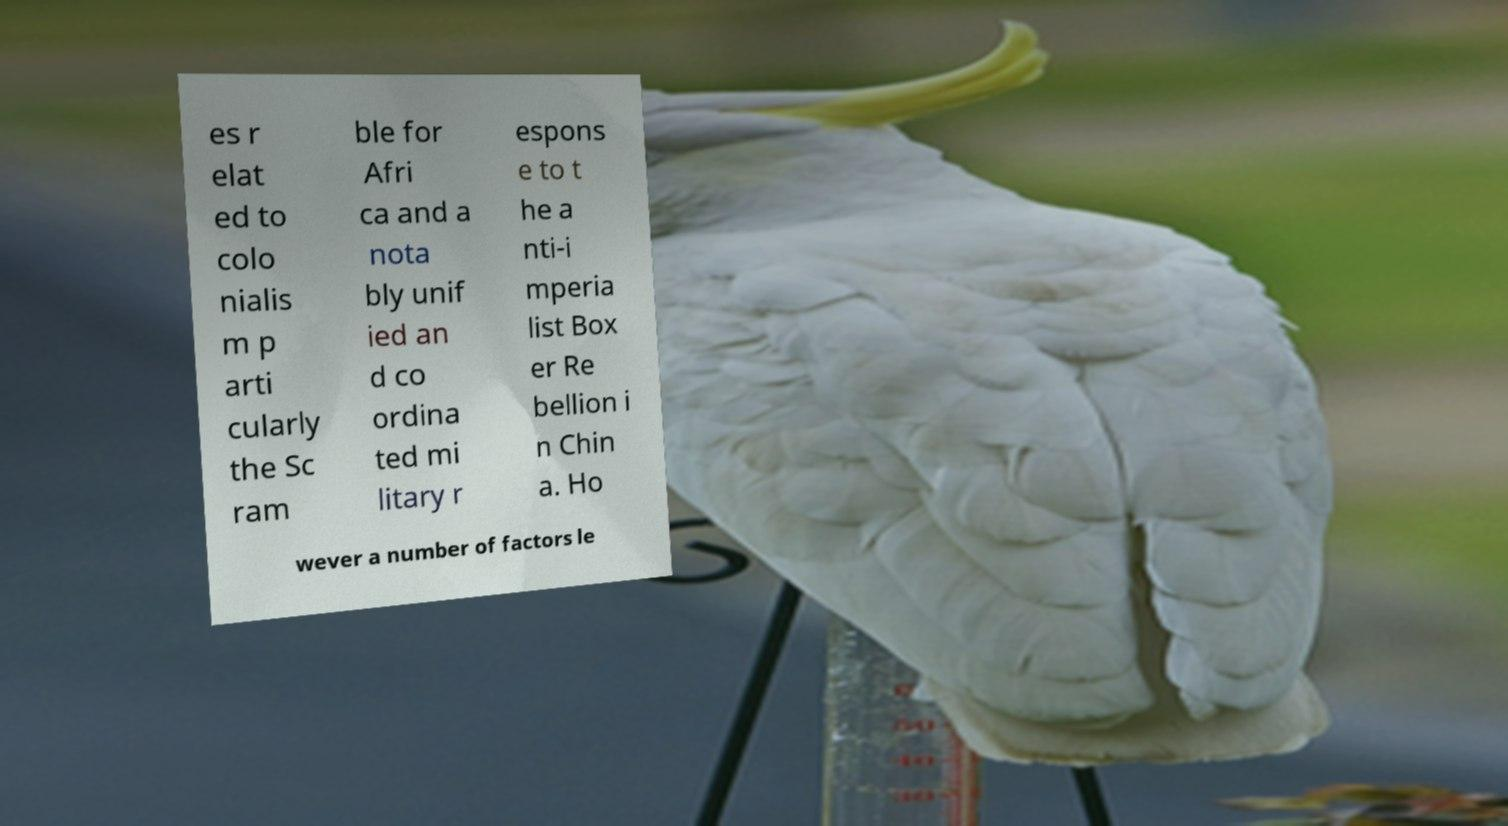What messages or text are displayed in this image? I need them in a readable, typed format. es r elat ed to colo nialis m p arti cularly the Sc ram ble for Afri ca and a nota bly unif ied an d co ordina ted mi litary r espons e to t he a nti-i mperia list Box er Re bellion i n Chin a. Ho wever a number of factors le 